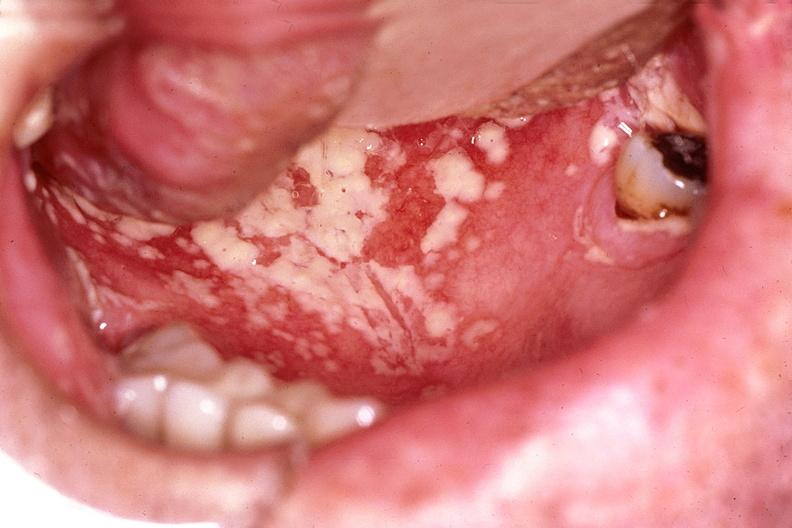s gastrointestinal present?
Answer the question using a single word or phrase. Yes 